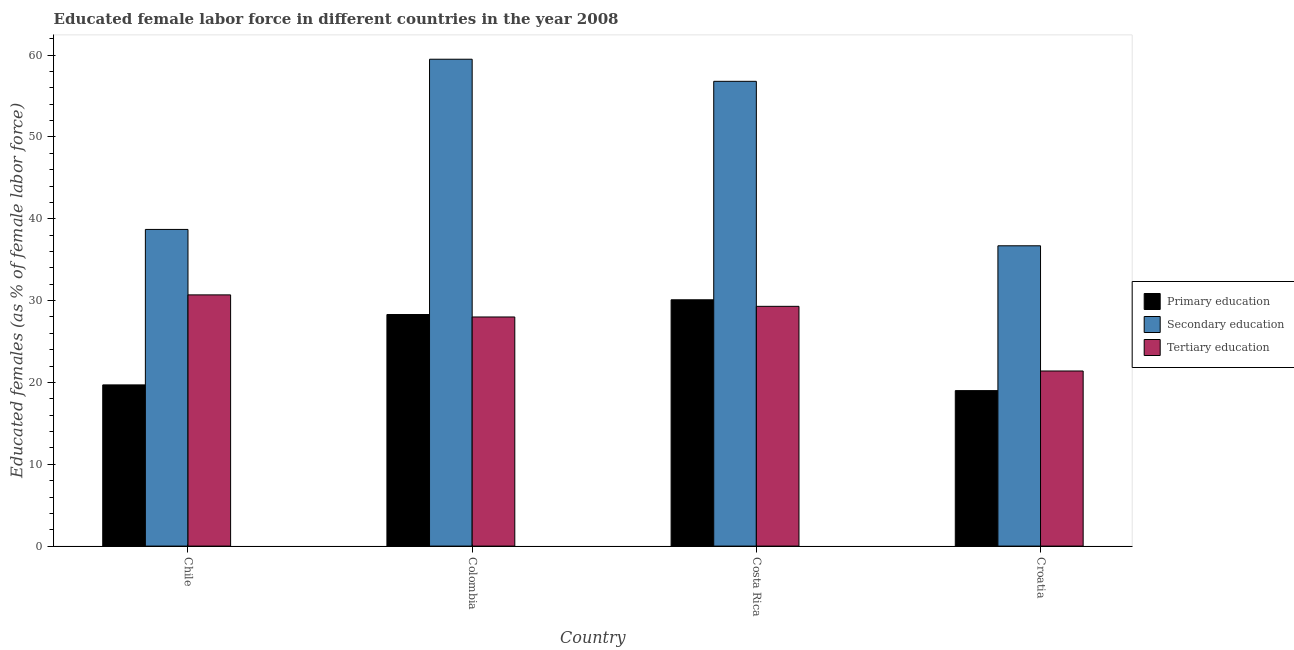How many different coloured bars are there?
Offer a terse response. 3. How many bars are there on the 1st tick from the left?
Offer a terse response. 3. How many bars are there on the 4th tick from the right?
Keep it short and to the point. 3. In how many cases, is the number of bars for a given country not equal to the number of legend labels?
Give a very brief answer. 0. What is the percentage of female labor force who received secondary education in Chile?
Provide a short and direct response. 38.7. Across all countries, what is the maximum percentage of female labor force who received primary education?
Make the answer very short. 30.1. Across all countries, what is the minimum percentage of female labor force who received tertiary education?
Offer a very short reply. 21.4. In which country was the percentage of female labor force who received tertiary education maximum?
Give a very brief answer. Chile. In which country was the percentage of female labor force who received primary education minimum?
Your response must be concise. Croatia. What is the total percentage of female labor force who received secondary education in the graph?
Ensure brevity in your answer.  191.7. What is the difference between the percentage of female labor force who received tertiary education in Colombia and that in Croatia?
Ensure brevity in your answer.  6.6. What is the difference between the percentage of female labor force who received secondary education in Croatia and the percentage of female labor force who received primary education in Chile?
Ensure brevity in your answer.  17. What is the average percentage of female labor force who received tertiary education per country?
Provide a short and direct response. 27.35. What is the difference between the percentage of female labor force who received secondary education and percentage of female labor force who received primary education in Colombia?
Make the answer very short. 31.2. What is the ratio of the percentage of female labor force who received secondary education in Chile to that in Croatia?
Your response must be concise. 1.05. Is the percentage of female labor force who received tertiary education in Colombia less than that in Croatia?
Your answer should be compact. No. What is the difference between the highest and the second highest percentage of female labor force who received tertiary education?
Provide a short and direct response. 1.4. What is the difference between the highest and the lowest percentage of female labor force who received primary education?
Offer a terse response. 11.1. In how many countries, is the percentage of female labor force who received secondary education greater than the average percentage of female labor force who received secondary education taken over all countries?
Your response must be concise. 2. What does the 1st bar from the right in Colombia represents?
Your answer should be very brief. Tertiary education. How many bars are there?
Provide a short and direct response. 12. Are all the bars in the graph horizontal?
Make the answer very short. No. Does the graph contain any zero values?
Provide a short and direct response. No. Does the graph contain grids?
Provide a short and direct response. No. Where does the legend appear in the graph?
Offer a terse response. Center right. What is the title of the graph?
Your response must be concise. Educated female labor force in different countries in the year 2008. Does "Transport services" appear as one of the legend labels in the graph?
Offer a terse response. No. What is the label or title of the X-axis?
Provide a short and direct response. Country. What is the label or title of the Y-axis?
Provide a succinct answer. Educated females (as % of female labor force). What is the Educated females (as % of female labor force) of Primary education in Chile?
Your response must be concise. 19.7. What is the Educated females (as % of female labor force) of Secondary education in Chile?
Provide a succinct answer. 38.7. What is the Educated females (as % of female labor force) in Tertiary education in Chile?
Give a very brief answer. 30.7. What is the Educated females (as % of female labor force) in Primary education in Colombia?
Offer a very short reply. 28.3. What is the Educated females (as % of female labor force) in Secondary education in Colombia?
Keep it short and to the point. 59.5. What is the Educated females (as % of female labor force) in Primary education in Costa Rica?
Provide a succinct answer. 30.1. What is the Educated females (as % of female labor force) in Secondary education in Costa Rica?
Make the answer very short. 56.8. What is the Educated females (as % of female labor force) of Tertiary education in Costa Rica?
Your answer should be compact. 29.3. What is the Educated females (as % of female labor force) of Primary education in Croatia?
Make the answer very short. 19. What is the Educated females (as % of female labor force) of Secondary education in Croatia?
Your answer should be compact. 36.7. What is the Educated females (as % of female labor force) in Tertiary education in Croatia?
Make the answer very short. 21.4. Across all countries, what is the maximum Educated females (as % of female labor force) in Primary education?
Ensure brevity in your answer.  30.1. Across all countries, what is the maximum Educated females (as % of female labor force) in Secondary education?
Ensure brevity in your answer.  59.5. Across all countries, what is the maximum Educated females (as % of female labor force) in Tertiary education?
Keep it short and to the point. 30.7. Across all countries, what is the minimum Educated females (as % of female labor force) of Primary education?
Make the answer very short. 19. Across all countries, what is the minimum Educated females (as % of female labor force) of Secondary education?
Your answer should be very brief. 36.7. Across all countries, what is the minimum Educated females (as % of female labor force) in Tertiary education?
Your response must be concise. 21.4. What is the total Educated females (as % of female labor force) of Primary education in the graph?
Make the answer very short. 97.1. What is the total Educated females (as % of female labor force) in Secondary education in the graph?
Keep it short and to the point. 191.7. What is the total Educated females (as % of female labor force) in Tertiary education in the graph?
Offer a terse response. 109.4. What is the difference between the Educated females (as % of female labor force) of Primary education in Chile and that in Colombia?
Your response must be concise. -8.6. What is the difference between the Educated females (as % of female labor force) of Secondary education in Chile and that in Colombia?
Keep it short and to the point. -20.8. What is the difference between the Educated females (as % of female labor force) in Tertiary education in Chile and that in Colombia?
Provide a short and direct response. 2.7. What is the difference between the Educated females (as % of female labor force) of Primary education in Chile and that in Costa Rica?
Make the answer very short. -10.4. What is the difference between the Educated females (as % of female labor force) of Secondary education in Chile and that in Costa Rica?
Provide a succinct answer. -18.1. What is the difference between the Educated females (as % of female labor force) of Tertiary education in Chile and that in Costa Rica?
Ensure brevity in your answer.  1.4. What is the difference between the Educated females (as % of female labor force) in Primary education in Chile and that in Croatia?
Your answer should be very brief. 0.7. What is the difference between the Educated females (as % of female labor force) of Secondary education in Chile and that in Croatia?
Your response must be concise. 2. What is the difference between the Educated females (as % of female labor force) in Primary education in Colombia and that in Costa Rica?
Your response must be concise. -1.8. What is the difference between the Educated females (as % of female labor force) in Secondary education in Colombia and that in Costa Rica?
Your response must be concise. 2.7. What is the difference between the Educated females (as % of female labor force) of Tertiary education in Colombia and that in Costa Rica?
Give a very brief answer. -1.3. What is the difference between the Educated females (as % of female labor force) in Primary education in Colombia and that in Croatia?
Ensure brevity in your answer.  9.3. What is the difference between the Educated females (as % of female labor force) in Secondary education in Colombia and that in Croatia?
Ensure brevity in your answer.  22.8. What is the difference between the Educated females (as % of female labor force) of Secondary education in Costa Rica and that in Croatia?
Your response must be concise. 20.1. What is the difference between the Educated females (as % of female labor force) of Tertiary education in Costa Rica and that in Croatia?
Your answer should be very brief. 7.9. What is the difference between the Educated females (as % of female labor force) in Primary education in Chile and the Educated females (as % of female labor force) in Secondary education in Colombia?
Your answer should be very brief. -39.8. What is the difference between the Educated females (as % of female labor force) of Primary education in Chile and the Educated females (as % of female labor force) of Secondary education in Costa Rica?
Ensure brevity in your answer.  -37.1. What is the difference between the Educated females (as % of female labor force) in Primary education in Chile and the Educated females (as % of female labor force) in Tertiary education in Croatia?
Give a very brief answer. -1.7. What is the difference between the Educated females (as % of female labor force) of Secondary education in Chile and the Educated females (as % of female labor force) of Tertiary education in Croatia?
Provide a short and direct response. 17.3. What is the difference between the Educated females (as % of female labor force) in Primary education in Colombia and the Educated females (as % of female labor force) in Secondary education in Costa Rica?
Offer a very short reply. -28.5. What is the difference between the Educated females (as % of female labor force) of Secondary education in Colombia and the Educated females (as % of female labor force) of Tertiary education in Costa Rica?
Your response must be concise. 30.2. What is the difference between the Educated females (as % of female labor force) of Primary education in Colombia and the Educated females (as % of female labor force) of Secondary education in Croatia?
Offer a very short reply. -8.4. What is the difference between the Educated females (as % of female labor force) in Secondary education in Colombia and the Educated females (as % of female labor force) in Tertiary education in Croatia?
Your response must be concise. 38.1. What is the difference between the Educated females (as % of female labor force) in Primary education in Costa Rica and the Educated females (as % of female labor force) in Tertiary education in Croatia?
Your answer should be compact. 8.7. What is the difference between the Educated females (as % of female labor force) in Secondary education in Costa Rica and the Educated females (as % of female labor force) in Tertiary education in Croatia?
Give a very brief answer. 35.4. What is the average Educated females (as % of female labor force) in Primary education per country?
Your response must be concise. 24.27. What is the average Educated females (as % of female labor force) in Secondary education per country?
Keep it short and to the point. 47.92. What is the average Educated females (as % of female labor force) in Tertiary education per country?
Keep it short and to the point. 27.35. What is the difference between the Educated females (as % of female labor force) of Primary education and Educated females (as % of female labor force) of Tertiary education in Chile?
Offer a terse response. -11. What is the difference between the Educated females (as % of female labor force) of Secondary education and Educated females (as % of female labor force) of Tertiary education in Chile?
Make the answer very short. 8. What is the difference between the Educated females (as % of female labor force) of Primary education and Educated females (as % of female labor force) of Secondary education in Colombia?
Provide a short and direct response. -31.2. What is the difference between the Educated females (as % of female labor force) in Primary education and Educated females (as % of female labor force) in Tertiary education in Colombia?
Give a very brief answer. 0.3. What is the difference between the Educated females (as % of female labor force) in Secondary education and Educated females (as % of female labor force) in Tertiary education in Colombia?
Provide a short and direct response. 31.5. What is the difference between the Educated females (as % of female labor force) in Primary education and Educated females (as % of female labor force) in Secondary education in Costa Rica?
Give a very brief answer. -26.7. What is the difference between the Educated females (as % of female labor force) in Primary education and Educated females (as % of female labor force) in Secondary education in Croatia?
Your response must be concise. -17.7. What is the ratio of the Educated females (as % of female labor force) of Primary education in Chile to that in Colombia?
Your answer should be compact. 0.7. What is the ratio of the Educated females (as % of female labor force) in Secondary education in Chile to that in Colombia?
Make the answer very short. 0.65. What is the ratio of the Educated females (as % of female labor force) of Tertiary education in Chile to that in Colombia?
Make the answer very short. 1.1. What is the ratio of the Educated females (as % of female labor force) in Primary education in Chile to that in Costa Rica?
Give a very brief answer. 0.65. What is the ratio of the Educated females (as % of female labor force) of Secondary education in Chile to that in Costa Rica?
Make the answer very short. 0.68. What is the ratio of the Educated females (as % of female labor force) in Tertiary education in Chile to that in Costa Rica?
Your answer should be very brief. 1.05. What is the ratio of the Educated females (as % of female labor force) in Primary education in Chile to that in Croatia?
Keep it short and to the point. 1.04. What is the ratio of the Educated females (as % of female labor force) in Secondary education in Chile to that in Croatia?
Give a very brief answer. 1.05. What is the ratio of the Educated females (as % of female labor force) in Tertiary education in Chile to that in Croatia?
Provide a short and direct response. 1.43. What is the ratio of the Educated females (as % of female labor force) in Primary education in Colombia to that in Costa Rica?
Your response must be concise. 0.94. What is the ratio of the Educated females (as % of female labor force) in Secondary education in Colombia to that in Costa Rica?
Keep it short and to the point. 1.05. What is the ratio of the Educated females (as % of female labor force) of Tertiary education in Colombia to that in Costa Rica?
Provide a short and direct response. 0.96. What is the ratio of the Educated females (as % of female labor force) of Primary education in Colombia to that in Croatia?
Your response must be concise. 1.49. What is the ratio of the Educated females (as % of female labor force) of Secondary education in Colombia to that in Croatia?
Provide a short and direct response. 1.62. What is the ratio of the Educated females (as % of female labor force) in Tertiary education in Colombia to that in Croatia?
Ensure brevity in your answer.  1.31. What is the ratio of the Educated females (as % of female labor force) of Primary education in Costa Rica to that in Croatia?
Your answer should be compact. 1.58. What is the ratio of the Educated females (as % of female labor force) of Secondary education in Costa Rica to that in Croatia?
Offer a terse response. 1.55. What is the ratio of the Educated females (as % of female labor force) in Tertiary education in Costa Rica to that in Croatia?
Give a very brief answer. 1.37. What is the difference between the highest and the second highest Educated females (as % of female labor force) of Secondary education?
Make the answer very short. 2.7. What is the difference between the highest and the second highest Educated females (as % of female labor force) of Tertiary education?
Provide a short and direct response. 1.4. What is the difference between the highest and the lowest Educated females (as % of female labor force) of Secondary education?
Give a very brief answer. 22.8. What is the difference between the highest and the lowest Educated females (as % of female labor force) in Tertiary education?
Give a very brief answer. 9.3. 